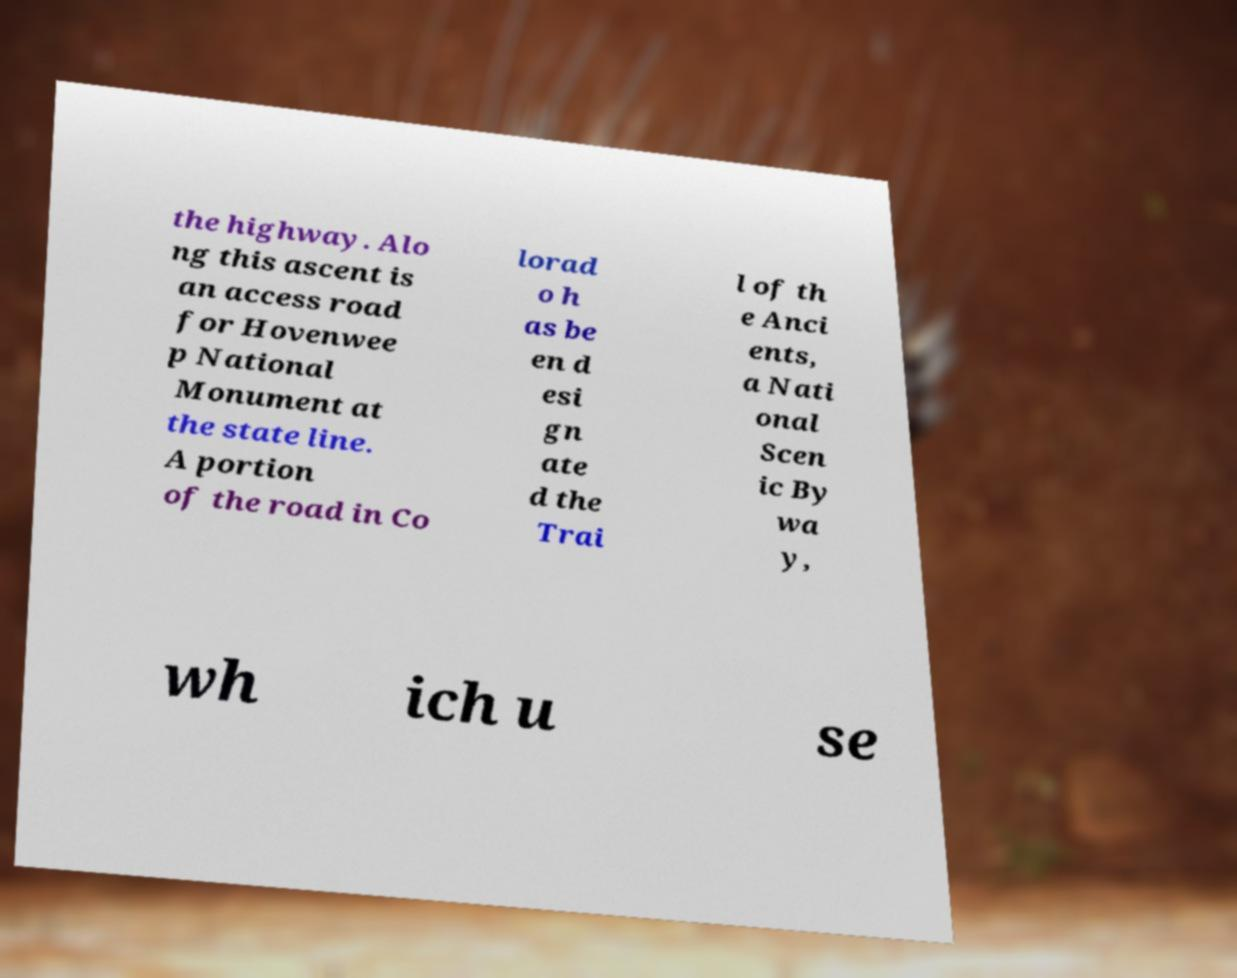Please identify and transcribe the text found in this image. the highway. Alo ng this ascent is an access road for Hovenwee p National Monument at the state line. A portion of the road in Co lorad o h as be en d esi gn ate d the Trai l of th e Anci ents, a Nati onal Scen ic By wa y, wh ich u se 